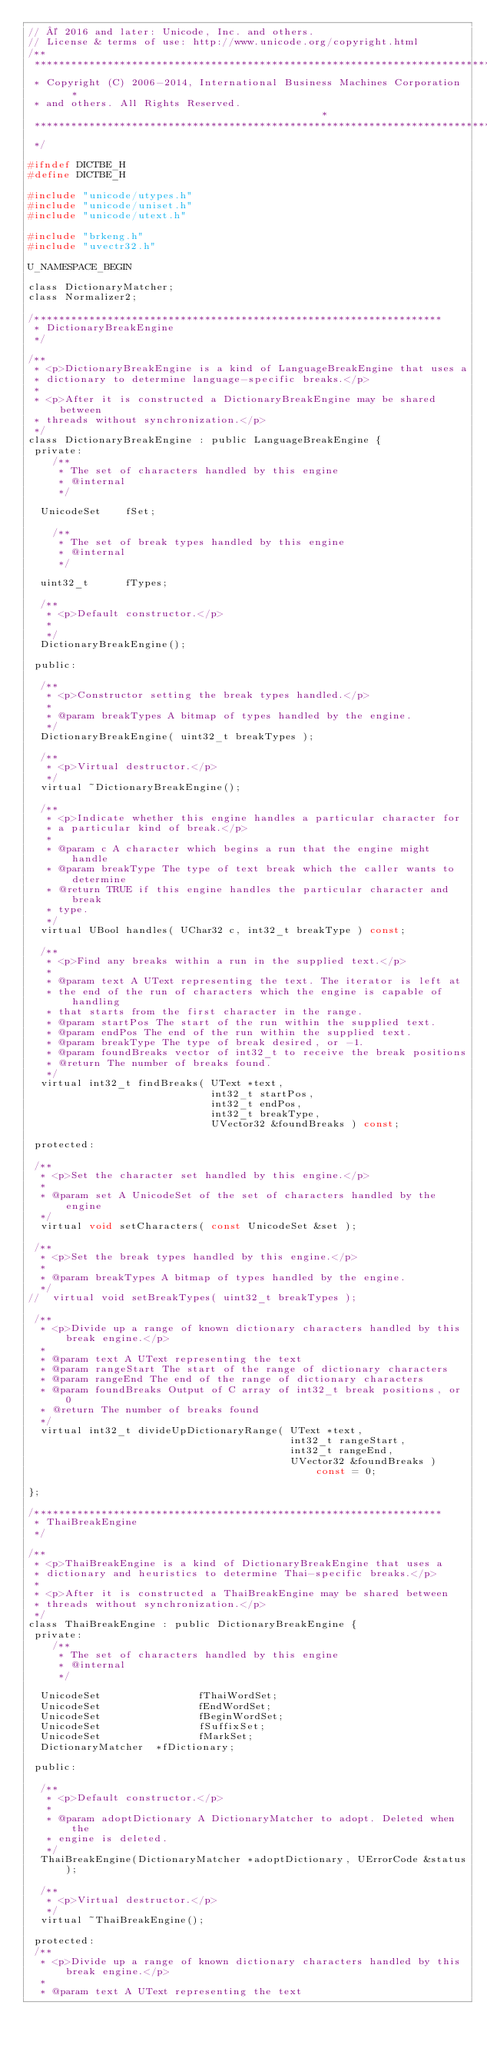Convert code to text. <code><loc_0><loc_0><loc_500><loc_500><_C_>// © 2016 and later: Unicode, Inc. and others.
// License & terms of use: http://www.unicode.org/copyright.html
/**
 *******************************************************************************
 * Copyright (C) 2006-2014, International Business Machines Corporation   *
 * and others. All Rights Reserved.                                            *
 *******************************************************************************
 */

#ifndef DICTBE_H
#define DICTBE_H

#include "unicode/utypes.h"
#include "unicode/uniset.h"
#include "unicode/utext.h"

#include "brkeng.h"
#include "uvectr32.h"

U_NAMESPACE_BEGIN

class DictionaryMatcher;
class Normalizer2;

/*******************************************************************
 * DictionaryBreakEngine
 */

/**
 * <p>DictionaryBreakEngine is a kind of LanguageBreakEngine that uses a
 * dictionary to determine language-specific breaks.</p>
 *
 * <p>After it is constructed a DictionaryBreakEngine may be shared between
 * threads without synchronization.</p>
 */
class DictionaryBreakEngine : public LanguageBreakEngine {
 private:
    /**
     * The set of characters handled by this engine
     * @internal
     */

  UnicodeSet    fSet;

    /**
     * The set of break types handled by this engine
     * @internal
     */

  uint32_t      fTypes;

  /**
   * <p>Default constructor.</p>
   *
   */
  DictionaryBreakEngine();

 public:

  /**
   * <p>Constructor setting the break types handled.</p>
   *
   * @param breakTypes A bitmap of types handled by the engine.
   */
  DictionaryBreakEngine( uint32_t breakTypes );

  /**
   * <p>Virtual destructor.</p>
   */
  virtual ~DictionaryBreakEngine();

  /**
   * <p>Indicate whether this engine handles a particular character for
   * a particular kind of break.</p>
   *
   * @param c A character which begins a run that the engine might handle
   * @param breakType The type of text break which the caller wants to determine
   * @return TRUE if this engine handles the particular character and break
   * type.
   */
  virtual UBool handles( UChar32 c, int32_t breakType ) const;

  /**
   * <p>Find any breaks within a run in the supplied text.</p>
   *
   * @param text A UText representing the text. The iterator is left at
   * the end of the run of characters which the engine is capable of handling
   * that starts from the first character in the range.
   * @param startPos The start of the run within the supplied text.
   * @param endPos The end of the run within the supplied text.
   * @param breakType The type of break desired, or -1.
   * @param foundBreaks vector of int32_t to receive the break positions
   * @return The number of breaks found.
   */
  virtual int32_t findBreaks( UText *text,
                              int32_t startPos,
                              int32_t endPos,
                              int32_t breakType,
                              UVector32 &foundBreaks ) const;

 protected:

 /**
  * <p>Set the character set handled by this engine.</p>
  *
  * @param set A UnicodeSet of the set of characters handled by the engine
  */
  virtual void setCharacters( const UnicodeSet &set );

 /**
  * <p>Set the break types handled by this engine.</p>
  *
  * @param breakTypes A bitmap of types handled by the engine.
  */
//  virtual void setBreakTypes( uint32_t breakTypes );

 /**
  * <p>Divide up a range of known dictionary characters handled by this break engine.</p>
  *
  * @param text A UText representing the text
  * @param rangeStart The start of the range of dictionary characters
  * @param rangeEnd The end of the range of dictionary characters
  * @param foundBreaks Output of C array of int32_t break positions, or 0
  * @return The number of breaks found
  */
  virtual int32_t divideUpDictionaryRange( UText *text,
                                           int32_t rangeStart,
                                           int32_t rangeEnd,
                                           UVector32 &foundBreaks ) const = 0;

};

/*******************************************************************
 * ThaiBreakEngine
 */

/**
 * <p>ThaiBreakEngine is a kind of DictionaryBreakEngine that uses a
 * dictionary and heuristics to determine Thai-specific breaks.</p>
 *
 * <p>After it is constructed a ThaiBreakEngine may be shared between
 * threads without synchronization.</p>
 */
class ThaiBreakEngine : public DictionaryBreakEngine {
 private:
    /**
     * The set of characters handled by this engine
     * @internal
     */

  UnicodeSet                fThaiWordSet;
  UnicodeSet                fEndWordSet;
  UnicodeSet                fBeginWordSet;
  UnicodeSet                fSuffixSet;
  UnicodeSet                fMarkSet;
  DictionaryMatcher  *fDictionary;

 public:

  /**
   * <p>Default constructor.</p>
   *
   * @param adoptDictionary A DictionaryMatcher to adopt. Deleted when the
   * engine is deleted.
   */
  ThaiBreakEngine(DictionaryMatcher *adoptDictionary, UErrorCode &status);

  /**
   * <p>Virtual destructor.</p>
   */
  virtual ~ThaiBreakEngine();

 protected:
 /**
  * <p>Divide up a range of known dictionary characters handled by this break engine.</p>
  *
  * @param text A UText representing the text</code> 